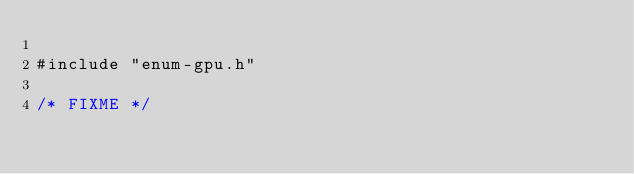<code> <loc_0><loc_0><loc_500><loc_500><_Cuda_>
#include "enum-gpu.h"

/* FIXME */

</code> 